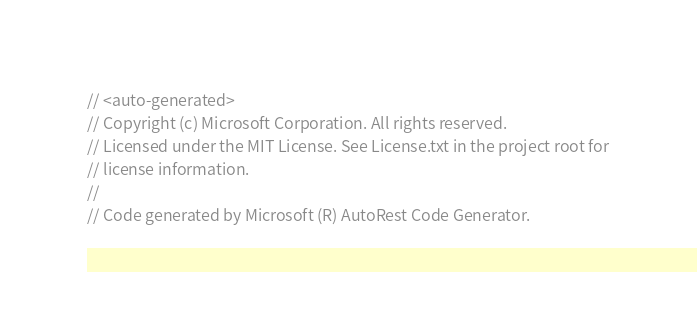Convert code to text. <code><loc_0><loc_0><loc_500><loc_500><_C#_>// <auto-generated>
// Copyright (c) Microsoft Corporation. All rights reserved.
// Licensed under the MIT License. See License.txt in the project root for
// license information.
//
// Code generated by Microsoft (R) AutoRest Code Generator.</code> 